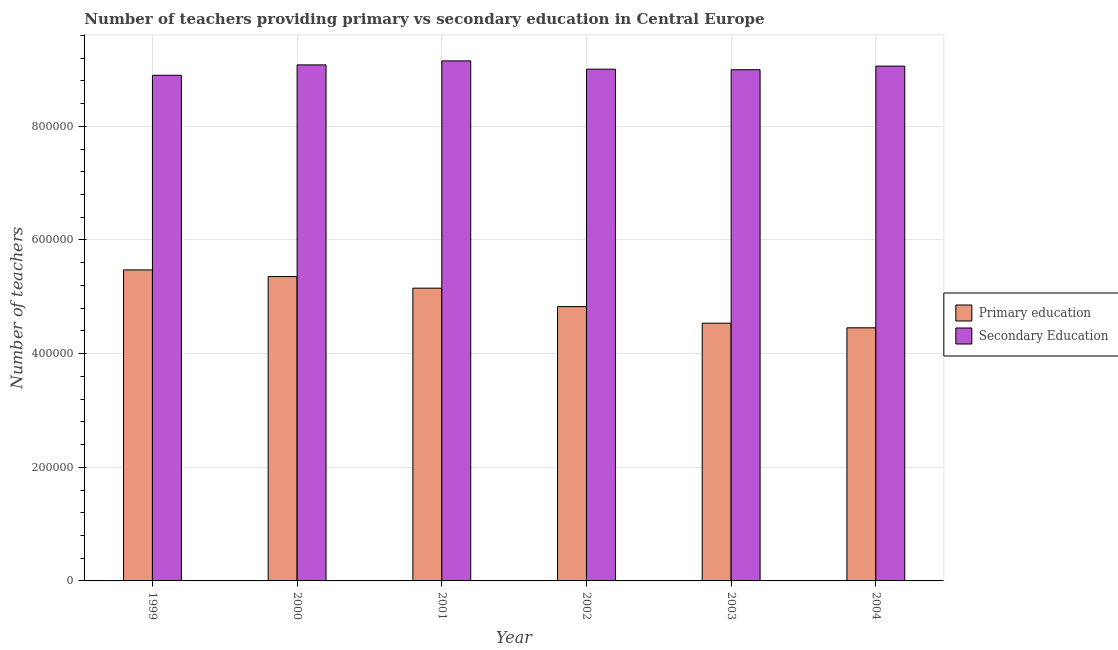How many bars are there on the 4th tick from the left?
Your answer should be compact. 2. How many bars are there on the 2nd tick from the right?
Your answer should be very brief. 2. What is the label of the 5th group of bars from the left?
Provide a succinct answer. 2003. In how many cases, is the number of bars for a given year not equal to the number of legend labels?
Offer a terse response. 0. What is the number of secondary teachers in 1999?
Make the answer very short. 8.90e+05. Across all years, what is the maximum number of primary teachers?
Provide a succinct answer. 5.47e+05. Across all years, what is the minimum number of primary teachers?
Ensure brevity in your answer.  4.45e+05. In which year was the number of primary teachers minimum?
Provide a succinct answer. 2004. What is the total number of secondary teachers in the graph?
Give a very brief answer. 5.42e+06. What is the difference between the number of primary teachers in 1999 and that in 2001?
Offer a very short reply. 3.21e+04. What is the difference between the number of primary teachers in 1999 and the number of secondary teachers in 2003?
Your answer should be compact. 9.37e+04. What is the average number of secondary teachers per year?
Give a very brief answer. 9.03e+05. In how many years, is the number of secondary teachers greater than 120000?
Provide a succinct answer. 6. What is the ratio of the number of secondary teachers in 1999 to that in 2001?
Give a very brief answer. 0.97. Is the number of primary teachers in 1999 less than that in 2003?
Your answer should be compact. No. Is the difference between the number of secondary teachers in 2000 and 2003 greater than the difference between the number of primary teachers in 2000 and 2003?
Provide a short and direct response. No. What is the difference between the highest and the second highest number of secondary teachers?
Your response must be concise. 7063.25. What is the difference between the highest and the lowest number of primary teachers?
Offer a terse response. 1.02e+05. In how many years, is the number of secondary teachers greater than the average number of secondary teachers taken over all years?
Provide a short and direct response. 3. What does the 2nd bar from the left in 2004 represents?
Your answer should be very brief. Secondary Education. What does the 1st bar from the right in 2001 represents?
Ensure brevity in your answer.  Secondary Education. What is the difference between two consecutive major ticks on the Y-axis?
Provide a succinct answer. 2.00e+05. Does the graph contain any zero values?
Offer a very short reply. No. Where does the legend appear in the graph?
Provide a succinct answer. Center right. How are the legend labels stacked?
Your answer should be very brief. Vertical. What is the title of the graph?
Offer a very short reply. Number of teachers providing primary vs secondary education in Central Europe. What is the label or title of the X-axis?
Make the answer very short. Year. What is the label or title of the Y-axis?
Provide a short and direct response. Number of teachers. What is the Number of teachers of Primary education in 1999?
Offer a terse response. 5.47e+05. What is the Number of teachers in Secondary Education in 1999?
Keep it short and to the point. 8.90e+05. What is the Number of teachers of Primary education in 2000?
Provide a succinct answer. 5.36e+05. What is the Number of teachers in Secondary Education in 2000?
Give a very brief answer. 9.08e+05. What is the Number of teachers of Primary education in 2001?
Keep it short and to the point. 5.15e+05. What is the Number of teachers in Secondary Education in 2001?
Give a very brief answer. 9.15e+05. What is the Number of teachers in Primary education in 2002?
Ensure brevity in your answer.  4.83e+05. What is the Number of teachers of Secondary Education in 2002?
Provide a succinct answer. 9.01e+05. What is the Number of teachers of Primary education in 2003?
Provide a succinct answer. 4.54e+05. What is the Number of teachers of Secondary Education in 2003?
Your answer should be compact. 9.00e+05. What is the Number of teachers of Primary education in 2004?
Your response must be concise. 4.45e+05. What is the Number of teachers in Secondary Education in 2004?
Keep it short and to the point. 9.06e+05. Across all years, what is the maximum Number of teachers in Primary education?
Provide a succinct answer. 5.47e+05. Across all years, what is the maximum Number of teachers in Secondary Education?
Your answer should be compact. 9.15e+05. Across all years, what is the minimum Number of teachers of Primary education?
Keep it short and to the point. 4.45e+05. Across all years, what is the minimum Number of teachers of Secondary Education?
Offer a very short reply. 8.90e+05. What is the total Number of teachers of Primary education in the graph?
Make the answer very short. 2.98e+06. What is the total Number of teachers of Secondary Education in the graph?
Make the answer very short. 5.42e+06. What is the difference between the Number of teachers in Primary education in 1999 and that in 2000?
Make the answer very short. 1.17e+04. What is the difference between the Number of teachers in Secondary Education in 1999 and that in 2000?
Provide a short and direct response. -1.83e+04. What is the difference between the Number of teachers of Primary education in 1999 and that in 2001?
Your response must be concise. 3.21e+04. What is the difference between the Number of teachers of Secondary Education in 1999 and that in 2001?
Offer a terse response. -2.53e+04. What is the difference between the Number of teachers in Primary education in 1999 and that in 2002?
Make the answer very short. 6.46e+04. What is the difference between the Number of teachers in Secondary Education in 1999 and that in 2002?
Offer a terse response. -1.07e+04. What is the difference between the Number of teachers of Primary education in 1999 and that in 2003?
Your answer should be very brief. 9.37e+04. What is the difference between the Number of teachers of Secondary Education in 1999 and that in 2003?
Give a very brief answer. -9751.56. What is the difference between the Number of teachers in Primary education in 1999 and that in 2004?
Your answer should be compact. 1.02e+05. What is the difference between the Number of teachers in Secondary Education in 1999 and that in 2004?
Offer a terse response. -1.61e+04. What is the difference between the Number of teachers in Primary education in 2000 and that in 2001?
Ensure brevity in your answer.  2.04e+04. What is the difference between the Number of teachers of Secondary Education in 2000 and that in 2001?
Offer a very short reply. -7063.25. What is the difference between the Number of teachers in Primary education in 2000 and that in 2002?
Your response must be concise. 5.29e+04. What is the difference between the Number of teachers in Secondary Education in 2000 and that in 2002?
Keep it short and to the point. 7528. What is the difference between the Number of teachers in Primary education in 2000 and that in 2003?
Your response must be concise. 8.21e+04. What is the difference between the Number of teachers of Secondary Education in 2000 and that in 2003?
Your response must be concise. 8521.56. What is the difference between the Number of teachers in Primary education in 2000 and that in 2004?
Ensure brevity in your answer.  9.02e+04. What is the difference between the Number of teachers in Secondary Education in 2000 and that in 2004?
Ensure brevity in your answer.  2147.69. What is the difference between the Number of teachers of Primary education in 2001 and that in 2002?
Make the answer very short. 3.25e+04. What is the difference between the Number of teachers in Secondary Education in 2001 and that in 2002?
Your answer should be compact. 1.46e+04. What is the difference between the Number of teachers in Primary education in 2001 and that in 2003?
Keep it short and to the point. 6.16e+04. What is the difference between the Number of teachers of Secondary Education in 2001 and that in 2003?
Provide a short and direct response. 1.56e+04. What is the difference between the Number of teachers in Primary education in 2001 and that in 2004?
Provide a short and direct response. 6.97e+04. What is the difference between the Number of teachers in Secondary Education in 2001 and that in 2004?
Give a very brief answer. 9210.94. What is the difference between the Number of teachers in Primary education in 2002 and that in 2003?
Offer a terse response. 2.92e+04. What is the difference between the Number of teachers in Secondary Education in 2002 and that in 2003?
Your answer should be very brief. 993.56. What is the difference between the Number of teachers in Primary education in 2002 and that in 2004?
Your answer should be very brief. 3.73e+04. What is the difference between the Number of teachers in Secondary Education in 2002 and that in 2004?
Your response must be concise. -5380.31. What is the difference between the Number of teachers of Primary education in 2003 and that in 2004?
Offer a terse response. 8121.78. What is the difference between the Number of teachers in Secondary Education in 2003 and that in 2004?
Provide a succinct answer. -6373.88. What is the difference between the Number of teachers in Primary education in 1999 and the Number of teachers in Secondary Education in 2000?
Keep it short and to the point. -3.61e+05. What is the difference between the Number of teachers in Primary education in 1999 and the Number of teachers in Secondary Education in 2001?
Provide a short and direct response. -3.68e+05. What is the difference between the Number of teachers of Primary education in 1999 and the Number of teachers of Secondary Education in 2002?
Ensure brevity in your answer.  -3.53e+05. What is the difference between the Number of teachers in Primary education in 1999 and the Number of teachers in Secondary Education in 2003?
Offer a terse response. -3.52e+05. What is the difference between the Number of teachers of Primary education in 1999 and the Number of teachers of Secondary Education in 2004?
Ensure brevity in your answer.  -3.59e+05. What is the difference between the Number of teachers in Primary education in 2000 and the Number of teachers in Secondary Education in 2001?
Your answer should be compact. -3.80e+05. What is the difference between the Number of teachers in Primary education in 2000 and the Number of teachers in Secondary Education in 2002?
Your response must be concise. -3.65e+05. What is the difference between the Number of teachers in Primary education in 2000 and the Number of teachers in Secondary Education in 2003?
Make the answer very short. -3.64e+05. What is the difference between the Number of teachers in Primary education in 2000 and the Number of teachers in Secondary Education in 2004?
Offer a very short reply. -3.70e+05. What is the difference between the Number of teachers of Primary education in 2001 and the Number of teachers of Secondary Education in 2002?
Offer a very short reply. -3.85e+05. What is the difference between the Number of teachers of Primary education in 2001 and the Number of teachers of Secondary Education in 2003?
Make the answer very short. -3.84e+05. What is the difference between the Number of teachers of Primary education in 2001 and the Number of teachers of Secondary Education in 2004?
Provide a short and direct response. -3.91e+05. What is the difference between the Number of teachers in Primary education in 2002 and the Number of teachers in Secondary Education in 2003?
Provide a short and direct response. -4.17e+05. What is the difference between the Number of teachers of Primary education in 2002 and the Number of teachers of Secondary Education in 2004?
Your answer should be very brief. -4.23e+05. What is the difference between the Number of teachers of Primary education in 2003 and the Number of teachers of Secondary Education in 2004?
Offer a terse response. -4.52e+05. What is the average Number of teachers in Primary education per year?
Your answer should be compact. 4.97e+05. What is the average Number of teachers in Secondary Education per year?
Your answer should be very brief. 9.03e+05. In the year 1999, what is the difference between the Number of teachers in Primary education and Number of teachers in Secondary Education?
Make the answer very short. -3.43e+05. In the year 2000, what is the difference between the Number of teachers of Primary education and Number of teachers of Secondary Education?
Keep it short and to the point. -3.73e+05. In the year 2001, what is the difference between the Number of teachers of Primary education and Number of teachers of Secondary Education?
Give a very brief answer. -4.00e+05. In the year 2002, what is the difference between the Number of teachers of Primary education and Number of teachers of Secondary Education?
Ensure brevity in your answer.  -4.18e+05. In the year 2003, what is the difference between the Number of teachers of Primary education and Number of teachers of Secondary Education?
Your response must be concise. -4.46e+05. In the year 2004, what is the difference between the Number of teachers in Primary education and Number of teachers in Secondary Education?
Your answer should be very brief. -4.61e+05. What is the ratio of the Number of teachers in Primary education in 1999 to that in 2000?
Your response must be concise. 1.02. What is the ratio of the Number of teachers in Secondary Education in 1999 to that in 2000?
Make the answer very short. 0.98. What is the ratio of the Number of teachers in Primary education in 1999 to that in 2001?
Provide a short and direct response. 1.06. What is the ratio of the Number of teachers of Secondary Education in 1999 to that in 2001?
Provide a succinct answer. 0.97. What is the ratio of the Number of teachers in Primary education in 1999 to that in 2002?
Make the answer very short. 1.13. What is the ratio of the Number of teachers in Secondary Education in 1999 to that in 2002?
Your response must be concise. 0.99. What is the ratio of the Number of teachers of Primary education in 1999 to that in 2003?
Your answer should be compact. 1.21. What is the ratio of the Number of teachers in Primary education in 1999 to that in 2004?
Offer a terse response. 1.23. What is the ratio of the Number of teachers in Secondary Education in 1999 to that in 2004?
Offer a very short reply. 0.98. What is the ratio of the Number of teachers in Primary education in 2000 to that in 2001?
Your answer should be very brief. 1.04. What is the ratio of the Number of teachers of Secondary Education in 2000 to that in 2001?
Provide a short and direct response. 0.99. What is the ratio of the Number of teachers of Primary education in 2000 to that in 2002?
Keep it short and to the point. 1.11. What is the ratio of the Number of teachers in Secondary Education in 2000 to that in 2002?
Provide a succinct answer. 1.01. What is the ratio of the Number of teachers in Primary education in 2000 to that in 2003?
Provide a short and direct response. 1.18. What is the ratio of the Number of teachers of Secondary Education in 2000 to that in 2003?
Offer a very short reply. 1.01. What is the ratio of the Number of teachers in Primary education in 2000 to that in 2004?
Make the answer very short. 1.2. What is the ratio of the Number of teachers of Secondary Education in 2000 to that in 2004?
Your answer should be compact. 1. What is the ratio of the Number of teachers of Primary education in 2001 to that in 2002?
Offer a very short reply. 1.07. What is the ratio of the Number of teachers in Secondary Education in 2001 to that in 2002?
Give a very brief answer. 1.02. What is the ratio of the Number of teachers in Primary education in 2001 to that in 2003?
Your answer should be very brief. 1.14. What is the ratio of the Number of teachers in Secondary Education in 2001 to that in 2003?
Your answer should be compact. 1.02. What is the ratio of the Number of teachers of Primary education in 2001 to that in 2004?
Your answer should be compact. 1.16. What is the ratio of the Number of teachers of Secondary Education in 2001 to that in 2004?
Your answer should be compact. 1.01. What is the ratio of the Number of teachers of Primary education in 2002 to that in 2003?
Make the answer very short. 1.06. What is the ratio of the Number of teachers in Secondary Education in 2002 to that in 2003?
Offer a terse response. 1. What is the ratio of the Number of teachers in Primary education in 2002 to that in 2004?
Your response must be concise. 1.08. What is the ratio of the Number of teachers of Secondary Education in 2002 to that in 2004?
Offer a very short reply. 0.99. What is the ratio of the Number of teachers in Primary education in 2003 to that in 2004?
Your answer should be very brief. 1.02. What is the ratio of the Number of teachers of Secondary Education in 2003 to that in 2004?
Keep it short and to the point. 0.99. What is the difference between the highest and the second highest Number of teachers of Primary education?
Provide a succinct answer. 1.17e+04. What is the difference between the highest and the second highest Number of teachers of Secondary Education?
Your response must be concise. 7063.25. What is the difference between the highest and the lowest Number of teachers in Primary education?
Your answer should be very brief. 1.02e+05. What is the difference between the highest and the lowest Number of teachers of Secondary Education?
Your answer should be compact. 2.53e+04. 